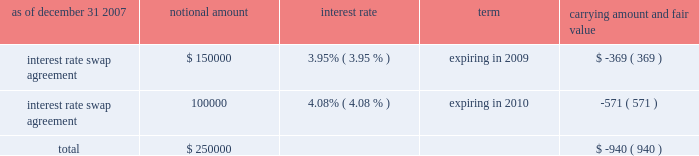American tower corporation and subsidiaries notes to consolidated financial statements 2014 ( continued ) market and lease the unused tower space on the broadcast towers ( the economic rights ) .
Tv azteca retains title to these towers and is responsible for their operation and maintenance .
The company is entitled to 100% ( 100 % ) of the revenues generated from leases with tenants on the unused space and is responsible for any incremental operating expenses associated with those tenants .
The term of the economic rights agreement is seventy years ; however , tv azteca has the right to purchase , at fair market value , the economic rights from the company at any time during the last fifty years of the agreement .
Should tv azteca elect to purchase the economic rights ( in whole or in part ) , it would also be obligated to repay a proportional amount of the loan discussed above at the time of such election .
The company 2019s obligation to pay tv azteca $ 1.5 million annually would also be reduced proportionally .
The company has accounted for the annual payment of $ 1.5 million as a capital lease ( initially recording an asset and a corresponding liability of approximately $ 18.6 million ) .
The capital lease asset and the discount on the note , which aggregate approximately $ 30.2 million , represent the cost to acquire the economic rights and are being amortized over the seventy-year life of the economic rights agreement .
On a quarterly basis , the company assesses the recoverability of its note receivable from tv azteca .
As of december 31 , 2007 and 2006 , the company has assessed the recoverability of the note receivable from tv azteca and concluded that no adjustment to its carrying value is required .
A former executive officer and former director of the company served as a director of tv azteca from december 1999 to february 2006 .
As of december 31 , 2007 and 2006 , the company also had other long-term notes receivable outstanding of approximately $ 4.3 million and $ 11.0 million , respectively .
Derivative financial instruments the company enters into interest rate protection agreements to manage exposure on the variable rate debt under its credit facilities and to manage variability in cash flows relating to forecasted interest payments .
Under these agreements , the company is exposed to credit risk to the extent that a counterparty fails to meet the terms of a contract .
Such exposure was limited to the current value of the contract at the time the counterparty fails to perform .
The company believes its contracts as of december 31 , 2007 and 2006 are with credit worthy institutions .
As of december 31 , 2007 and 2006 , the carrying amounts of the company 2019s derivative financial instruments , along with the estimated fair values of the related assets reflected in notes receivable and other long-term assets and ( liabilities ) reflected in other long-term liabilities in the accompanying consolidated balance sheet , are as follows ( in thousands except percentages ) : as of december 31 , 2007 notional amount interest rate term carrying amount and fair value .

The 3.95% ( 3.95 % ) notional swap was how much of the total notional swap principle? 
Computations: (150000 / 250000)
Answer: 0.6. 